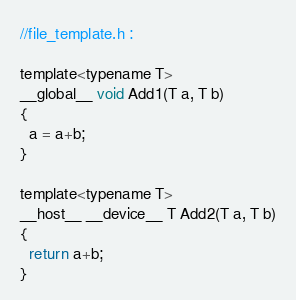Convert code to text. <code><loc_0><loc_0><loc_500><loc_500><_C_>//file_template.h :

template<typename T>
__global__ void Add1(T a, T b)
{
  a = a+b;
}

template<typename T>
__host__ __device__ T Add2(T a, T b)
{
  return a+b;
}</code> 